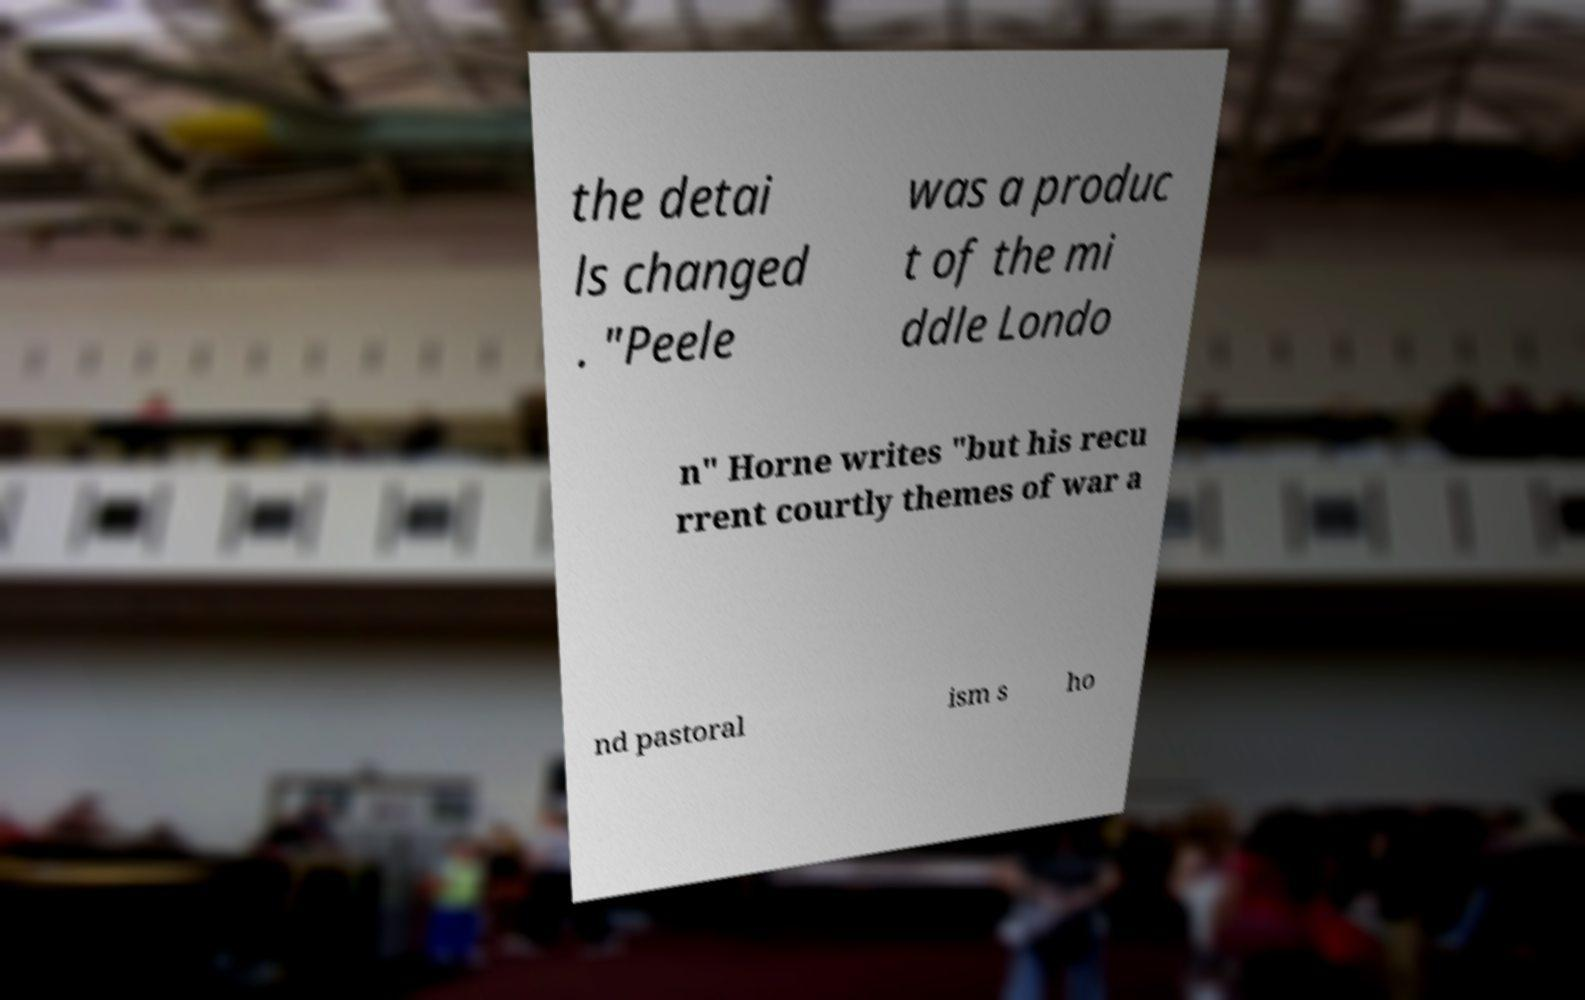Could you extract and type out the text from this image? the detai ls changed . "Peele was a produc t of the mi ddle Londo n" Horne writes "but his recu rrent courtly themes of war a nd pastoral ism s ho 